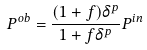<formula> <loc_0><loc_0><loc_500><loc_500>P ^ { o b } = { \frac { ( 1 + f ) \delta ^ { p } } { 1 + f \delta ^ { p } } } P ^ { i n }</formula> 